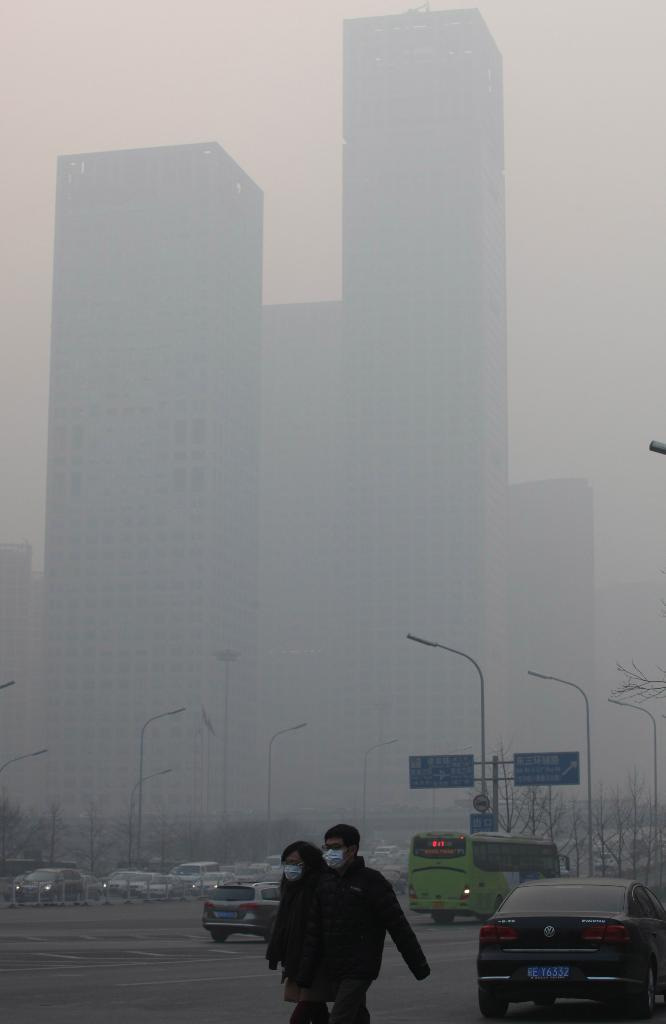What are the two people in the image doing? The two people in the image are walking on the road. What can be seen in the background of the image? In the background, there are vehicles, street poles, and buildings. What atmospheric conditions are present in the image? There is fog and smoke in the image. What type of net is being used by the lawyer in the image? There is no lawyer or net present in the image. Can you describe the frog's habitat in the image? There is no frog present in the image. 